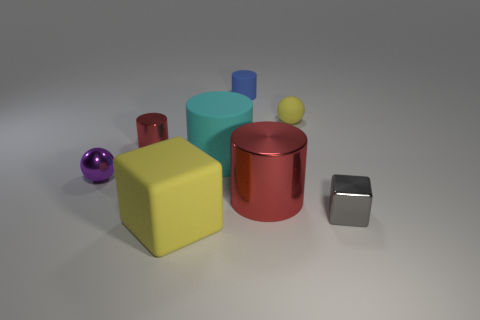There is a big matte thing behind the tiny gray metallic object; how many tiny metallic objects are right of it?
Ensure brevity in your answer.  1. There is another tiny thing that is the same shape as the small yellow object; what material is it?
Provide a short and direct response. Metal. How many yellow objects are rubber things or metal blocks?
Your response must be concise. 2. Are there any other things that are the same color as the big cube?
Your response must be concise. Yes. What color is the metal cylinder to the right of the cube that is on the left side of the tiny rubber ball?
Provide a succinct answer. Red. Is the number of tiny purple balls to the left of the rubber ball less than the number of shiny things that are to the right of the big cyan cylinder?
Ensure brevity in your answer.  Yes. There is a tiny sphere that is the same color as the large rubber block; what is it made of?
Offer a terse response. Rubber. What number of things are either small yellow rubber things that are behind the tiny red shiny cylinder or red metallic cubes?
Your answer should be very brief. 1. There is a ball on the right side of the blue thing; does it have the same size as the big cyan thing?
Ensure brevity in your answer.  No. Is the number of cyan cylinders in front of the purple shiny thing less than the number of matte things?
Provide a succinct answer. Yes. 